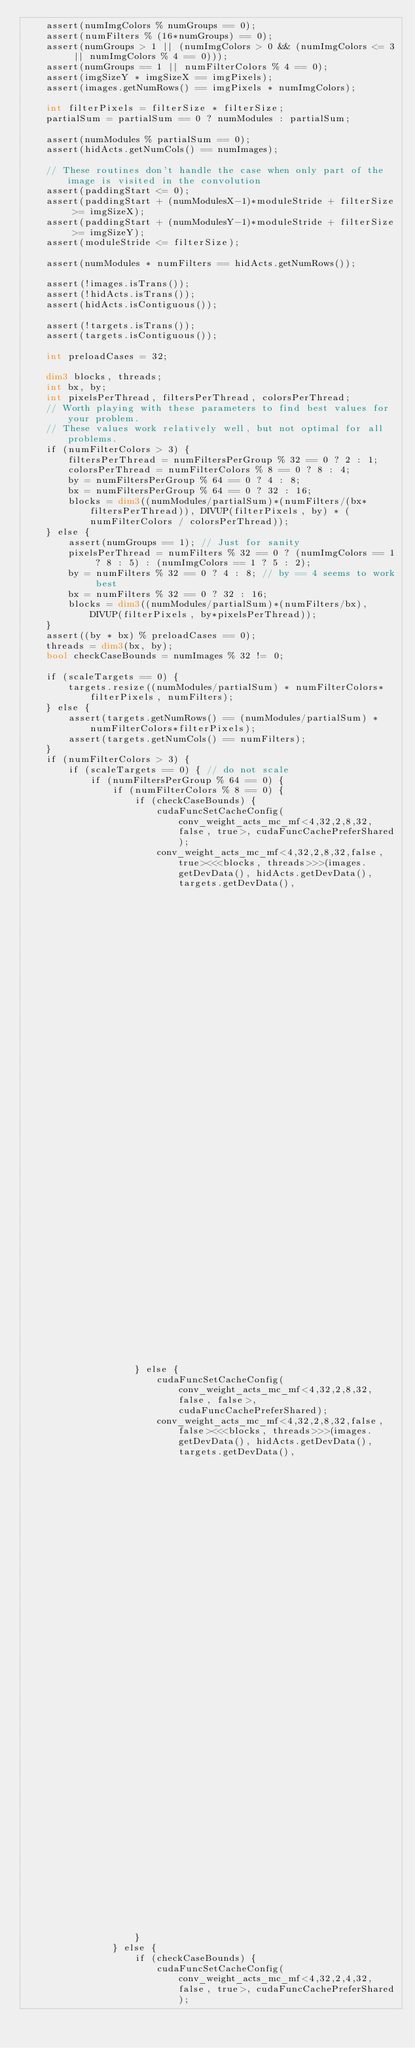<code> <loc_0><loc_0><loc_500><loc_500><_Cuda_>    assert(numImgColors % numGroups == 0);
    assert(numFilters % (16*numGroups) == 0);
    assert(numGroups > 1 || (numImgColors > 0 && (numImgColors <= 3 || numImgColors % 4 == 0)));
    assert(numGroups == 1 || numFilterColors % 4 == 0);
    assert(imgSizeY * imgSizeX == imgPixels);
    assert(images.getNumRows() == imgPixels * numImgColors);

    int filterPixels = filterSize * filterSize;
    partialSum = partialSum == 0 ? numModules : partialSum;

    assert(numModules % partialSum == 0);
    assert(hidActs.getNumCols() == numImages);

    // These routines don't handle the case when only part of the image is visited in the convolution
    assert(paddingStart <= 0);
    assert(paddingStart + (numModulesX-1)*moduleStride + filterSize >= imgSizeX);
    assert(paddingStart + (numModulesY-1)*moduleStride + filterSize >= imgSizeY);
    assert(moduleStride <= filterSize);
    
    assert(numModules * numFilters == hidActs.getNumRows());

    assert(!images.isTrans());
    assert(!hidActs.isTrans());
    assert(hidActs.isContiguous());

    assert(!targets.isTrans());
    assert(targets.isContiguous());
    
    int preloadCases = 32;

    dim3 blocks, threads;
    int bx, by;
    int pixelsPerThread, filtersPerThread, colorsPerThread;
    // Worth playing with these parameters to find best values for your problem.
    // These values work relatively well, but not optimal for all problems.
    if (numFilterColors > 3) {
        filtersPerThread = numFiltersPerGroup % 32 == 0 ? 2 : 1;
        colorsPerThread = numFilterColors % 8 == 0 ? 8 : 4;
        by = numFiltersPerGroup % 64 == 0 ? 4 : 8;
        bx = numFiltersPerGroup % 64 == 0 ? 32 : 16;
        blocks = dim3((numModules/partialSum)*(numFilters/(bx*filtersPerThread)), DIVUP(filterPixels, by) * (numFilterColors / colorsPerThread));
    } else {
        assert(numGroups == 1); // Just for sanity
        pixelsPerThread = numFilters % 32 == 0 ? (numImgColors == 1 ? 8 : 5) : (numImgColors == 1 ? 5 : 2);
        by = numFilters % 32 == 0 ? 4 : 8; // by == 4 seems to work best
        bx = numFilters % 32 == 0 ? 32 : 16; 
        blocks = dim3((numModules/partialSum)*(numFilters/bx), DIVUP(filterPixels, by*pixelsPerThread));
    }
    assert((by * bx) % preloadCases == 0);
    threads = dim3(bx, by);
    bool checkCaseBounds = numImages % 32 != 0;
    
    if (scaleTargets == 0) {
        targets.resize((numModules/partialSum) * numFilterColors*filterPixels, numFilters);
    } else {
        assert(targets.getNumRows() == (numModules/partialSum) * numFilterColors*filterPixels);
        assert(targets.getNumCols() == numFilters);
    }
    if (numFilterColors > 3) {
        if (scaleTargets == 0) { // do not scale
            if (numFiltersPerGroup % 64 == 0) {
                if (numFilterColors % 8 == 0) {
                    if (checkCaseBounds) {
                        cudaFuncSetCacheConfig(conv_weight_acts_mc_mf<4,32,2,8,32, false, true>, cudaFuncCachePreferShared);
                        conv_weight_acts_mc_mf<4,32,2,8,32,false, true><<<blocks, threads>>>(images.getDevData(), hidActs.getDevData(), targets.getDevData(),
                                                                                       numImages, numFilters, numModulesY, numModulesX, imgSizeY, imgSizeX, filterSize,
                                                                                       paddingStart, moduleStride, imgStride, numImgColors, numGroups, partialSum, scaleTargets, scaleOutput);
                    } else {
                        cudaFuncSetCacheConfig(conv_weight_acts_mc_mf<4,32,2,8,32, false, false>, cudaFuncCachePreferShared);
                        conv_weight_acts_mc_mf<4,32,2,8,32,false, false><<<blocks, threads>>>(images.getDevData(), hidActs.getDevData(), targets.getDevData(),
                                                                                       numImages, numFilters, numModulesY, numModulesX, imgSizeY, imgSizeX, filterSize,
                                                                                       paddingStart, moduleStride, imgStride, numImgColors, numGroups, partialSum, scaleTargets, scaleOutput);
                    }
                } else {
                    if (checkCaseBounds) {
                        cudaFuncSetCacheConfig(conv_weight_acts_mc_mf<4,32,2,4,32, false, true>, cudaFuncCachePreferShared);</code> 